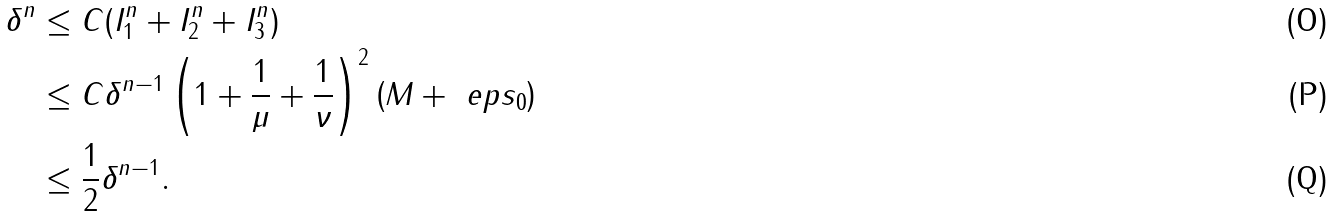Convert formula to latex. <formula><loc_0><loc_0><loc_500><loc_500>\delta ^ { n } & \leq C ( I _ { 1 } ^ { n } + I _ { 2 } ^ { n } + I _ { 3 } ^ { n } ) \\ & \leq C \delta ^ { n - 1 } \left ( 1 + \frac { 1 } { \mu } + \frac { 1 } { \nu } \right ) ^ { 2 } \left ( M + \ e p s _ { 0 } \right ) \\ & \leq \frac { 1 } { 2 } \delta ^ { n - 1 } .</formula> 